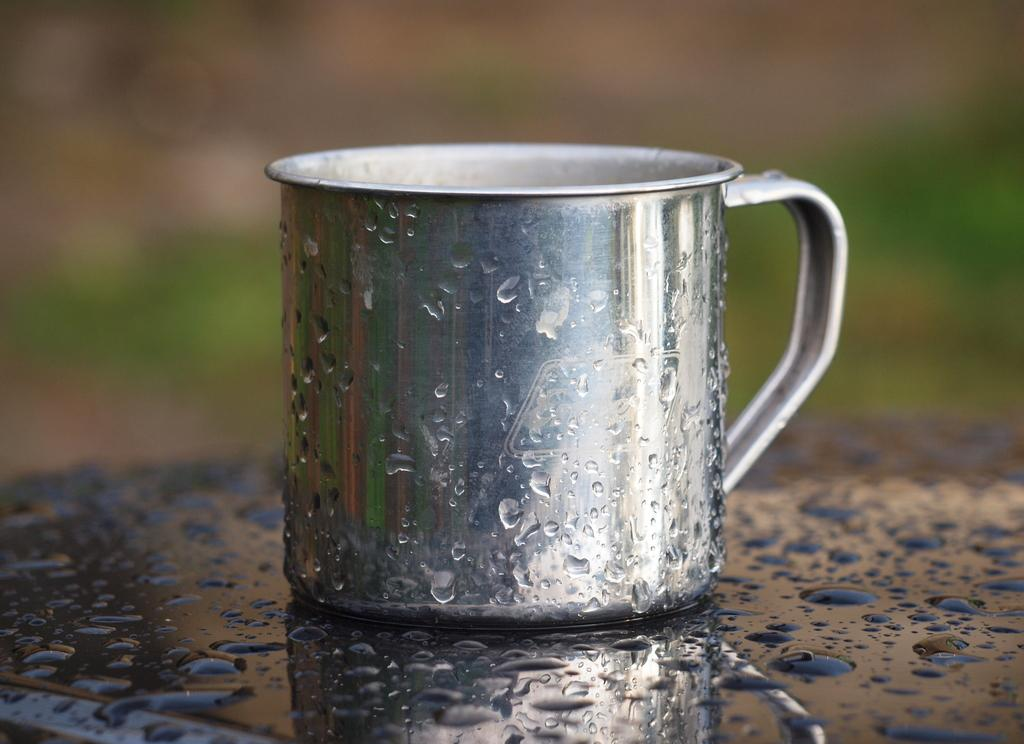What object is visible in the image that is typically used for holding liquids? There is a glass in the image. Where is the glass located in the image? The glass is kept on a table. Can you describe the appearance of the glass in the image? There are water droplets on the glass. Can you tell me how many snails are crawling on the glass in the image? There are no snails present on the glass in the image. What type of motion is the father performing in the image? There is no father present in the image, and therefore no motion can be attributed to him. 